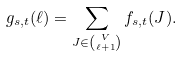<formula> <loc_0><loc_0><loc_500><loc_500>g _ { s , t } ( \ell ) = \sum _ { J \in \binom { V } { \ell + 1 } } f _ { s , t } ( J ) .</formula> 